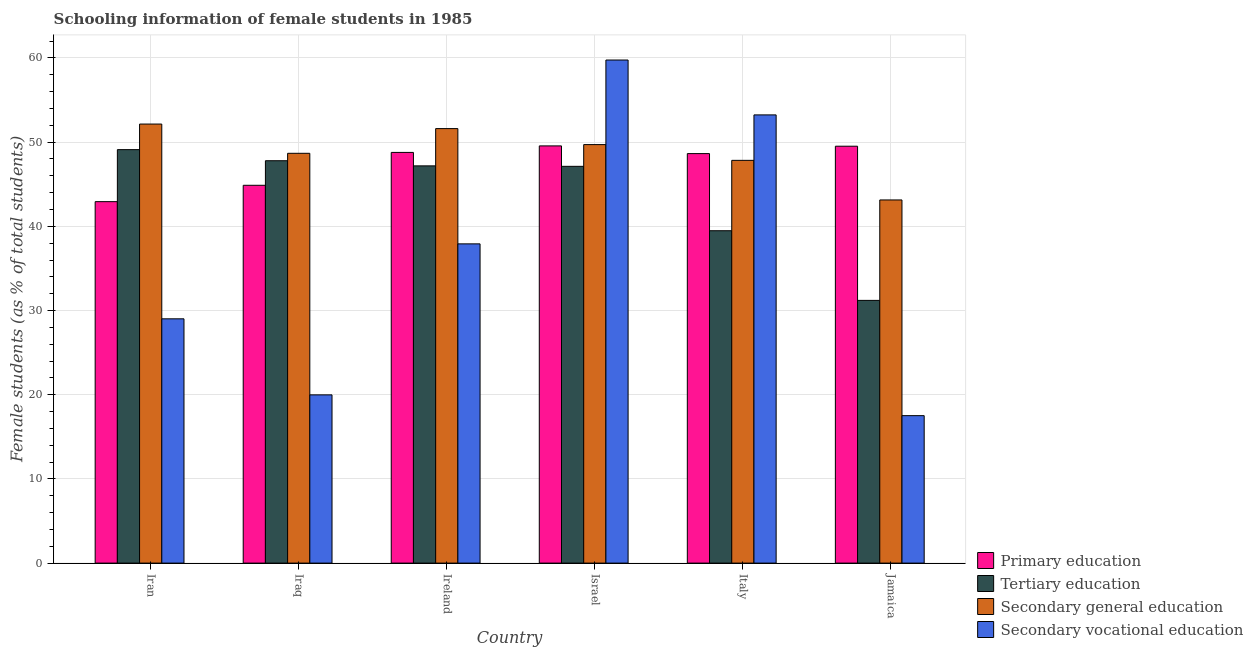How many groups of bars are there?
Give a very brief answer. 6. Are the number of bars per tick equal to the number of legend labels?
Give a very brief answer. Yes. How many bars are there on the 5th tick from the left?
Your answer should be very brief. 4. What is the label of the 4th group of bars from the left?
Ensure brevity in your answer.  Israel. In how many cases, is the number of bars for a given country not equal to the number of legend labels?
Your response must be concise. 0. What is the percentage of female students in tertiary education in Ireland?
Your answer should be compact. 47.18. Across all countries, what is the maximum percentage of female students in secondary vocational education?
Ensure brevity in your answer.  59.76. Across all countries, what is the minimum percentage of female students in secondary vocational education?
Offer a terse response. 17.51. In which country was the percentage of female students in primary education maximum?
Offer a very short reply. Israel. In which country was the percentage of female students in secondary vocational education minimum?
Provide a succinct answer. Jamaica. What is the total percentage of female students in primary education in the graph?
Make the answer very short. 284.31. What is the difference between the percentage of female students in primary education in Iraq and that in Italy?
Make the answer very short. -3.76. What is the difference between the percentage of female students in primary education in Iran and the percentage of female students in secondary education in Iraq?
Offer a terse response. -5.74. What is the average percentage of female students in secondary vocational education per country?
Your response must be concise. 36.24. What is the difference between the percentage of female students in secondary vocational education and percentage of female students in tertiary education in Israel?
Ensure brevity in your answer.  12.63. What is the ratio of the percentage of female students in primary education in Israel to that in Italy?
Offer a terse response. 1.02. Is the percentage of female students in secondary vocational education in Iran less than that in Ireland?
Give a very brief answer. Yes. What is the difference between the highest and the second highest percentage of female students in secondary vocational education?
Ensure brevity in your answer.  6.52. What is the difference between the highest and the lowest percentage of female students in secondary vocational education?
Offer a terse response. 42.24. Is the sum of the percentage of female students in secondary education in Iran and Jamaica greater than the maximum percentage of female students in secondary vocational education across all countries?
Make the answer very short. Yes. Is it the case that in every country, the sum of the percentage of female students in secondary vocational education and percentage of female students in tertiary education is greater than the sum of percentage of female students in secondary education and percentage of female students in primary education?
Offer a terse response. No. What does the 2nd bar from the left in Iran represents?
Make the answer very short. Tertiary education. What does the 3rd bar from the right in Iran represents?
Provide a short and direct response. Tertiary education. How many bars are there?
Your answer should be very brief. 24. What is the difference between two consecutive major ticks on the Y-axis?
Your answer should be very brief. 10. How are the legend labels stacked?
Ensure brevity in your answer.  Vertical. What is the title of the graph?
Provide a short and direct response. Schooling information of female students in 1985. Does "Fiscal policy" appear as one of the legend labels in the graph?
Provide a short and direct response. No. What is the label or title of the Y-axis?
Give a very brief answer. Female students (as % of total students). What is the Female students (as % of total students) in Primary education in Iran?
Give a very brief answer. 42.93. What is the Female students (as % of total students) of Tertiary education in Iran?
Make the answer very short. 49.11. What is the Female students (as % of total students) in Secondary general education in Iran?
Your response must be concise. 52.15. What is the Female students (as % of total students) of Secondary vocational education in Iran?
Offer a very short reply. 29.02. What is the Female students (as % of total students) in Primary education in Iraq?
Make the answer very short. 44.88. What is the Female students (as % of total students) in Tertiary education in Iraq?
Your answer should be very brief. 47.79. What is the Female students (as % of total students) in Secondary general education in Iraq?
Your answer should be compact. 48.68. What is the Female students (as % of total students) of Secondary vocational education in Iraq?
Offer a terse response. 19.98. What is the Female students (as % of total students) in Primary education in Ireland?
Keep it short and to the point. 48.78. What is the Female students (as % of total students) in Tertiary education in Ireland?
Provide a succinct answer. 47.18. What is the Female students (as % of total students) of Secondary general education in Ireland?
Offer a very short reply. 51.61. What is the Female students (as % of total students) of Secondary vocational education in Ireland?
Your answer should be very brief. 37.92. What is the Female students (as % of total students) in Primary education in Israel?
Your answer should be very brief. 49.56. What is the Female students (as % of total students) of Tertiary education in Israel?
Make the answer very short. 47.13. What is the Female students (as % of total students) in Secondary general education in Israel?
Make the answer very short. 49.71. What is the Female students (as % of total students) in Secondary vocational education in Israel?
Provide a short and direct response. 59.76. What is the Female students (as % of total students) in Primary education in Italy?
Ensure brevity in your answer.  48.64. What is the Female students (as % of total students) of Tertiary education in Italy?
Offer a very short reply. 39.48. What is the Female students (as % of total students) in Secondary general education in Italy?
Give a very brief answer. 47.84. What is the Female students (as % of total students) of Secondary vocational education in Italy?
Ensure brevity in your answer.  53.24. What is the Female students (as % of total students) in Primary education in Jamaica?
Ensure brevity in your answer.  49.52. What is the Female students (as % of total students) in Tertiary education in Jamaica?
Your answer should be very brief. 31.21. What is the Female students (as % of total students) in Secondary general education in Jamaica?
Ensure brevity in your answer.  43.14. What is the Female students (as % of total students) in Secondary vocational education in Jamaica?
Provide a succinct answer. 17.51. Across all countries, what is the maximum Female students (as % of total students) of Primary education?
Provide a succinct answer. 49.56. Across all countries, what is the maximum Female students (as % of total students) of Tertiary education?
Make the answer very short. 49.11. Across all countries, what is the maximum Female students (as % of total students) in Secondary general education?
Provide a short and direct response. 52.15. Across all countries, what is the maximum Female students (as % of total students) of Secondary vocational education?
Ensure brevity in your answer.  59.76. Across all countries, what is the minimum Female students (as % of total students) in Primary education?
Provide a short and direct response. 42.93. Across all countries, what is the minimum Female students (as % of total students) in Tertiary education?
Offer a terse response. 31.21. Across all countries, what is the minimum Female students (as % of total students) in Secondary general education?
Your response must be concise. 43.14. Across all countries, what is the minimum Female students (as % of total students) of Secondary vocational education?
Your response must be concise. 17.51. What is the total Female students (as % of total students) of Primary education in the graph?
Give a very brief answer. 284.31. What is the total Female students (as % of total students) of Tertiary education in the graph?
Give a very brief answer. 261.9. What is the total Female students (as % of total students) in Secondary general education in the graph?
Provide a succinct answer. 293.12. What is the total Female students (as % of total students) in Secondary vocational education in the graph?
Ensure brevity in your answer.  217.43. What is the difference between the Female students (as % of total students) of Primary education in Iran and that in Iraq?
Keep it short and to the point. -1.94. What is the difference between the Female students (as % of total students) in Tertiary education in Iran and that in Iraq?
Provide a short and direct response. 1.32. What is the difference between the Female students (as % of total students) of Secondary general education in Iran and that in Iraq?
Offer a terse response. 3.47. What is the difference between the Female students (as % of total students) of Secondary vocational education in Iran and that in Iraq?
Give a very brief answer. 9.03. What is the difference between the Female students (as % of total students) of Primary education in Iran and that in Ireland?
Ensure brevity in your answer.  -5.85. What is the difference between the Female students (as % of total students) of Tertiary education in Iran and that in Ireland?
Keep it short and to the point. 1.93. What is the difference between the Female students (as % of total students) of Secondary general education in Iran and that in Ireland?
Your answer should be very brief. 0.54. What is the difference between the Female students (as % of total students) in Secondary vocational education in Iran and that in Ireland?
Give a very brief answer. -8.9. What is the difference between the Female students (as % of total students) of Primary education in Iran and that in Israel?
Your answer should be compact. -6.62. What is the difference between the Female students (as % of total students) of Tertiary education in Iran and that in Israel?
Give a very brief answer. 1.98. What is the difference between the Female students (as % of total students) of Secondary general education in Iran and that in Israel?
Your response must be concise. 2.44. What is the difference between the Female students (as % of total students) of Secondary vocational education in Iran and that in Israel?
Offer a very short reply. -30.74. What is the difference between the Female students (as % of total students) in Primary education in Iran and that in Italy?
Keep it short and to the point. -5.71. What is the difference between the Female students (as % of total students) of Tertiary education in Iran and that in Italy?
Your response must be concise. 9.63. What is the difference between the Female students (as % of total students) of Secondary general education in Iran and that in Italy?
Make the answer very short. 4.31. What is the difference between the Female students (as % of total students) in Secondary vocational education in Iran and that in Italy?
Your answer should be very brief. -24.22. What is the difference between the Female students (as % of total students) of Primary education in Iran and that in Jamaica?
Your answer should be compact. -6.59. What is the difference between the Female students (as % of total students) in Tertiary education in Iran and that in Jamaica?
Provide a succinct answer. 17.91. What is the difference between the Female students (as % of total students) of Secondary general education in Iran and that in Jamaica?
Offer a terse response. 9.01. What is the difference between the Female students (as % of total students) in Secondary vocational education in Iran and that in Jamaica?
Your answer should be compact. 11.5. What is the difference between the Female students (as % of total students) of Primary education in Iraq and that in Ireland?
Provide a succinct answer. -3.9. What is the difference between the Female students (as % of total students) of Tertiary education in Iraq and that in Ireland?
Your answer should be compact. 0.61. What is the difference between the Female students (as % of total students) of Secondary general education in Iraq and that in Ireland?
Your answer should be compact. -2.94. What is the difference between the Female students (as % of total students) in Secondary vocational education in Iraq and that in Ireland?
Keep it short and to the point. -17.94. What is the difference between the Female students (as % of total students) in Primary education in Iraq and that in Israel?
Provide a short and direct response. -4.68. What is the difference between the Female students (as % of total students) in Tertiary education in Iraq and that in Israel?
Provide a short and direct response. 0.67. What is the difference between the Female students (as % of total students) in Secondary general education in Iraq and that in Israel?
Offer a terse response. -1.03. What is the difference between the Female students (as % of total students) in Secondary vocational education in Iraq and that in Israel?
Offer a terse response. -39.77. What is the difference between the Female students (as % of total students) in Primary education in Iraq and that in Italy?
Give a very brief answer. -3.76. What is the difference between the Female students (as % of total students) of Tertiary education in Iraq and that in Italy?
Provide a short and direct response. 8.31. What is the difference between the Female students (as % of total students) in Secondary general education in Iraq and that in Italy?
Provide a succinct answer. 0.84. What is the difference between the Female students (as % of total students) in Secondary vocational education in Iraq and that in Italy?
Give a very brief answer. -33.26. What is the difference between the Female students (as % of total students) in Primary education in Iraq and that in Jamaica?
Keep it short and to the point. -4.64. What is the difference between the Female students (as % of total students) of Tertiary education in Iraq and that in Jamaica?
Keep it short and to the point. 16.59. What is the difference between the Female students (as % of total students) in Secondary general education in Iraq and that in Jamaica?
Make the answer very short. 5.54. What is the difference between the Female students (as % of total students) in Secondary vocational education in Iraq and that in Jamaica?
Provide a succinct answer. 2.47. What is the difference between the Female students (as % of total students) in Primary education in Ireland and that in Israel?
Offer a very short reply. -0.77. What is the difference between the Female students (as % of total students) of Tertiary education in Ireland and that in Israel?
Your answer should be compact. 0.06. What is the difference between the Female students (as % of total students) in Secondary general education in Ireland and that in Israel?
Provide a succinct answer. 1.9. What is the difference between the Female students (as % of total students) of Secondary vocational education in Ireland and that in Israel?
Give a very brief answer. -21.84. What is the difference between the Female students (as % of total students) of Primary education in Ireland and that in Italy?
Keep it short and to the point. 0.14. What is the difference between the Female students (as % of total students) of Tertiary education in Ireland and that in Italy?
Your response must be concise. 7.7. What is the difference between the Female students (as % of total students) of Secondary general education in Ireland and that in Italy?
Keep it short and to the point. 3.77. What is the difference between the Female students (as % of total students) of Secondary vocational education in Ireland and that in Italy?
Your answer should be very brief. -15.32. What is the difference between the Female students (as % of total students) in Primary education in Ireland and that in Jamaica?
Provide a succinct answer. -0.74. What is the difference between the Female students (as % of total students) in Tertiary education in Ireland and that in Jamaica?
Your answer should be compact. 15.98. What is the difference between the Female students (as % of total students) of Secondary general education in Ireland and that in Jamaica?
Your answer should be compact. 8.48. What is the difference between the Female students (as % of total students) in Secondary vocational education in Ireland and that in Jamaica?
Offer a terse response. 20.4. What is the difference between the Female students (as % of total students) of Primary education in Israel and that in Italy?
Provide a succinct answer. 0.92. What is the difference between the Female students (as % of total students) of Tertiary education in Israel and that in Italy?
Keep it short and to the point. 7.65. What is the difference between the Female students (as % of total students) of Secondary general education in Israel and that in Italy?
Your response must be concise. 1.87. What is the difference between the Female students (as % of total students) of Secondary vocational education in Israel and that in Italy?
Offer a very short reply. 6.52. What is the difference between the Female students (as % of total students) of Primary education in Israel and that in Jamaica?
Provide a succinct answer. 0.04. What is the difference between the Female students (as % of total students) of Tertiary education in Israel and that in Jamaica?
Ensure brevity in your answer.  15.92. What is the difference between the Female students (as % of total students) of Secondary general education in Israel and that in Jamaica?
Offer a terse response. 6.57. What is the difference between the Female students (as % of total students) in Secondary vocational education in Israel and that in Jamaica?
Provide a succinct answer. 42.24. What is the difference between the Female students (as % of total students) in Primary education in Italy and that in Jamaica?
Your answer should be very brief. -0.88. What is the difference between the Female students (as % of total students) of Tertiary education in Italy and that in Jamaica?
Offer a terse response. 8.27. What is the difference between the Female students (as % of total students) of Secondary general education in Italy and that in Jamaica?
Your answer should be very brief. 4.7. What is the difference between the Female students (as % of total students) of Secondary vocational education in Italy and that in Jamaica?
Offer a terse response. 35.72. What is the difference between the Female students (as % of total students) of Primary education in Iran and the Female students (as % of total students) of Tertiary education in Iraq?
Ensure brevity in your answer.  -4.86. What is the difference between the Female students (as % of total students) in Primary education in Iran and the Female students (as % of total students) in Secondary general education in Iraq?
Offer a terse response. -5.74. What is the difference between the Female students (as % of total students) of Primary education in Iran and the Female students (as % of total students) of Secondary vocational education in Iraq?
Give a very brief answer. 22.95. What is the difference between the Female students (as % of total students) of Tertiary education in Iran and the Female students (as % of total students) of Secondary general education in Iraq?
Offer a very short reply. 0.44. What is the difference between the Female students (as % of total students) of Tertiary education in Iran and the Female students (as % of total students) of Secondary vocational education in Iraq?
Keep it short and to the point. 29.13. What is the difference between the Female students (as % of total students) in Secondary general education in Iran and the Female students (as % of total students) in Secondary vocational education in Iraq?
Your answer should be compact. 32.17. What is the difference between the Female students (as % of total students) of Primary education in Iran and the Female students (as % of total students) of Tertiary education in Ireland?
Your response must be concise. -4.25. What is the difference between the Female students (as % of total students) of Primary education in Iran and the Female students (as % of total students) of Secondary general education in Ireland?
Give a very brief answer. -8.68. What is the difference between the Female students (as % of total students) of Primary education in Iran and the Female students (as % of total students) of Secondary vocational education in Ireland?
Keep it short and to the point. 5.01. What is the difference between the Female students (as % of total students) of Tertiary education in Iran and the Female students (as % of total students) of Secondary general education in Ireland?
Ensure brevity in your answer.  -2.5. What is the difference between the Female students (as % of total students) of Tertiary education in Iran and the Female students (as % of total students) of Secondary vocational education in Ireland?
Keep it short and to the point. 11.19. What is the difference between the Female students (as % of total students) of Secondary general education in Iran and the Female students (as % of total students) of Secondary vocational education in Ireland?
Give a very brief answer. 14.23. What is the difference between the Female students (as % of total students) of Primary education in Iran and the Female students (as % of total students) of Tertiary education in Israel?
Ensure brevity in your answer.  -4.19. What is the difference between the Female students (as % of total students) in Primary education in Iran and the Female students (as % of total students) in Secondary general education in Israel?
Provide a succinct answer. -6.78. What is the difference between the Female students (as % of total students) in Primary education in Iran and the Female students (as % of total students) in Secondary vocational education in Israel?
Offer a terse response. -16.82. What is the difference between the Female students (as % of total students) of Tertiary education in Iran and the Female students (as % of total students) of Secondary general education in Israel?
Your response must be concise. -0.6. What is the difference between the Female students (as % of total students) in Tertiary education in Iran and the Female students (as % of total students) in Secondary vocational education in Israel?
Your response must be concise. -10.64. What is the difference between the Female students (as % of total students) of Secondary general education in Iran and the Female students (as % of total students) of Secondary vocational education in Israel?
Make the answer very short. -7.61. What is the difference between the Female students (as % of total students) of Primary education in Iran and the Female students (as % of total students) of Tertiary education in Italy?
Provide a short and direct response. 3.45. What is the difference between the Female students (as % of total students) of Primary education in Iran and the Female students (as % of total students) of Secondary general education in Italy?
Offer a very short reply. -4.91. What is the difference between the Female students (as % of total students) of Primary education in Iran and the Female students (as % of total students) of Secondary vocational education in Italy?
Give a very brief answer. -10.3. What is the difference between the Female students (as % of total students) in Tertiary education in Iran and the Female students (as % of total students) in Secondary general education in Italy?
Your response must be concise. 1.27. What is the difference between the Female students (as % of total students) of Tertiary education in Iran and the Female students (as % of total students) of Secondary vocational education in Italy?
Provide a short and direct response. -4.13. What is the difference between the Female students (as % of total students) of Secondary general education in Iran and the Female students (as % of total students) of Secondary vocational education in Italy?
Provide a succinct answer. -1.09. What is the difference between the Female students (as % of total students) of Primary education in Iran and the Female students (as % of total students) of Tertiary education in Jamaica?
Give a very brief answer. 11.73. What is the difference between the Female students (as % of total students) of Primary education in Iran and the Female students (as % of total students) of Secondary general education in Jamaica?
Offer a terse response. -0.2. What is the difference between the Female students (as % of total students) in Primary education in Iran and the Female students (as % of total students) in Secondary vocational education in Jamaica?
Offer a very short reply. 25.42. What is the difference between the Female students (as % of total students) in Tertiary education in Iran and the Female students (as % of total students) in Secondary general education in Jamaica?
Make the answer very short. 5.98. What is the difference between the Female students (as % of total students) in Tertiary education in Iran and the Female students (as % of total students) in Secondary vocational education in Jamaica?
Make the answer very short. 31.6. What is the difference between the Female students (as % of total students) of Secondary general education in Iran and the Female students (as % of total students) of Secondary vocational education in Jamaica?
Your response must be concise. 34.64. What is the difference between the Female students (as % of total students) of Primary education in Iraq and the Female students (as % of total students) of Tertiary education in Ireland?
Offer a very short reply. -2.31. What is the difference between the Female students (as % of total students) of Primary education in Iraq and the Female students (as % of total students) of Secondary general education in Ireland?
Your response must be concise. -6.73. What is the difference between the Female students (as % of total students) in Primary education in Iraq and the Female students (as % of total students) in Secondary vocational education in Ireland?
Give a very brief answer. 6.96. What is the difference between the Female students (as % of total students) of Tertiary education in Iraq and the Female students (as % of total students) of Secondary general education in Ireland?
Give a very brief answer. -3.82. What is the difference between the Female students (as % of total students) of Tertiary education in Iraq and the Female students (as % of total students) of Secondary vocational education in Ireland?
Your answer should be compact. 9.87. What is the difference between the Female students (as % of total students) in Secondary general education in Iraq and the Female students (as % of total students) in Secondary vocational education in Ireland?
Provide a succinct answer. 10.76. What is the difference between the Female students (as % of total students) of Primary education in Iraq and the Female students (as % of total students) of Tertiary education in Israel?
Ensure brevity in your answer.  -2.25. What is the difference between the Female students (as % of total students) in Primary education in Iraq and the Female students (as % of total students) in Secondary general education in Israel?
Your answer should be very brief. -4.83. What is the difference between the Female students (as % of total students) in Primary education in Iraq and the Female students (as % of total students) in Secondary vocational education in Israel?
Offer a terse response. -14.88. What is the difference between the Female students (as % of total students) of Tertiary education in Iraq and the Female students (as % of total students) of Secondary general education in Israel?
Provide a succinct answer. -1.92. What is the difference between the Female students (as % of total students) in Tertiary education in Iraq and the Female students (as % of total students) in Secondary vocational education in Israel?
Make the answer very short. -11.96. What is the difference between the Female students (as % of total students) in Secondary general education in Iraq and the Female students (as % of total students) in Secondary vocational education in Israel?
Keep it short and to the point. -11.08. What is the difference between the Female students (as % of total students) of Primary education in Iraq and the Female students (as % of total students) of Tertiary education in Italy?
Your response must be concise. 5.4. What is the difference between the Female students (as % of total students) in Primary education in Iraq and the Female students (as % of total students) in Secondary general education in Italy?
Ensure brevity in your answer.  -2.96. What is the difference between the Female students (as % of total students) in Primary education in Iraq and the Female students (as % of total students) in Secondary vocational education in Italy?
Provide a succinct answer. -8.36. What is the difference between the Female students (as % of total students) in Tertiary education in Iraq and the Female students (as % of total students) in Secondary general education in Italy?
Keep it short and to the point. -0.05. What is the difference between the Female students (as % of total students) of Tertiary education in Iraq and the Female students (as % of total students) of Secondary vocational education in Italy?
Provide a short and direct response. -5.45. What is the difference between the Female students (as % of total students) of Secondary general education in Iraq and the Female students (as % of total students) of Secondary vocational education in Italy?
Your answer should be very brief. -4.56. What is the difference between the Female students (as % of total students) of Primary education in Iraq and the Female students (as % of total students) of Tertiary education in Jamaica?
Provide a short and direct response. 13.67. What is the difference between the Female students (as % of total students) in Primary education in Iraq and the Female students (as % of total students) in Secondary general education in Jamaica?
Your answer should be compact. 1.74. What is the difference between the Female students (as % of total students) in Primary education in Iraq and the Female students (as % of total students) in Secondary vocational education in Jamaica?
Offer a very short reply. 27.36. What is the difference between the Female students (as % of total students) of Tertiary education in Iraq and the Female students (as % of total students) of Secondary general education in Jamaica?
Make the answer very short. 4.66. What is the difference between the Female students (as % of total students) in Tertiary education in Iraq and the Female students (as % of total students) in Secondary vocational education in Jamaica?
Make the answer very short. 30.28. What is the difference between the Female students (as % of total students) in Secondary general education in Iraq and the Female students (as % of total students) in Secondary vocational education in Jamaica?
Keep it short and to the point. 31.16. What is the difference between the Female students (as % of total students) in Primary education in Ireland and the Female students (as % of total students) in Tertiary education in Israel?
Provide a succinct answer. 1.65. What is the difference between the Female students (as % of total students) in Primary education in Ireland and the Female students (as % of total students) in Secondary general education in Israel?
Your response must be concise. -0.93. What is the difference between the Female students (as % of total students) of Primary education in Ireland and the Female students (as % of total students) of Secondary vocational education in Israel?
Offer a very short reply. -10.97. What is the difference between the Female students (as % of total students) in Tertiary education in Ireland and the Female students (as % of total students) in Secondary general education in Israel?
Offer a very short reply. -2.53. What is the difference between the Female students (as % of total students) of Tertiary education in Ireland and the Female students (as % of total students) of Secondary vocational education in Israel?
Your answer should be compact. -12.57. What is the difference between the Female students (as % of total students) of Secondary general education in Ireland and the Female students (as % of total students) of Secondary vocational education in Israel?
Keep it short and to the point. -8.14. What is the difference between the Female students (as % of total students) of Primary education in Ireland and the Female students (as % of total students) of Tertiary education in Italy?
Give a very brief answer. 9.3. What is the difference between the Female students (as % of total students) of Primary education in Ireland and the Female students (as % of total students) of Secondary general education in Italy?
Keep it short and to the point. 0.94. What is the difference between the Female students (as % of total students) in Primary education in Ireland and the Female students (as % of total students) in Secondary vocational education in Italy?
Make the answer very short. -4.46. What is the difference between the Female students (as % of total students) in Tertiary education in Ireland and the Female students (as % of total students) in Secondary general education in Italy?
Offer a very short reply. -0.66. What is the difference between the Female students (as % of total students) in Tertiary education in Ireland and the Female students (as % of total students) in Secondary vocational education in Italy?
Keep it short and to the point. -6.06. What is the difference between the Female students (as % of total students) of Secondary general education in Ireland and the Female students (as % of total students) of Secondary vocational education in Italy?
Offer a very short reply. -1.63. What is the difference between the Female students (as % of total students) in Primary education in Ireland and the Female students (as % of total students) in Tertiary education in Jamaica?
Keep it short and to the point. 17.58. What is the difference between the Female students (as % of total students) in Primary education in Ireland and the Female students (as % of total students) in Secondary general education in Jamaica?
Ensure brevity in your answer.  5.65. What is the difference between the Female students (as % of total students) in Primary education in Ireland and the Female students (as % of total students) in Secondary vocational education in Jamaica?
Provide a short and direct response. 31.27. What is the difference between the Female students (as % of total students) in Tertiary education in Ireland and the Female students (as % of total students) in Secondary general education in Jamaica?
Give a very brief answer. 4.05. What is the difference between the Female students (as % of total students) of Tertiary education in Ireland and the Female students (as % of total students) of Secondary vocational education in Jamaica?
Give a very brief answer. 29.67. What is the difference between the Female students (as % of total students) in Secondary general education in Ireland and the Female students (as % of total students) in Secondary vocational education in Jamaica?
Keep it short and to the point. 34.1. What is the difference between the Female students (as % of total students) of Primary education in Israel and the Female students (as % of total students) of Tertiary education in Italy?
Provide a short and direct response. 10.08. What is the difference between the Female students (as % of total students) in Primary education in Israel and the Female students (as % of total students) in Secondary general education in Italy?
Make the answer very short. 1.72. What is the difference between the Female students (as % of total students) of Primary education in Israel and the Female students (as % of total students) of Secondary vocational education in Italy?
Keep it short and to the point. -3.68. What is the difference between the Female students (as % of total students) of Tertiary education in Israel and the Female students (as % of total students) of Secondary general education in Italy?
Give a very brief answer. -0.71. What is the difference between the Female students (as % of total students) of Tertiary education in Israel and the Female students (as % of total students) of Secondary vocational education in Italy?
Give a very brief answer. -6.11. What is the difference between the Female students (as % of total students) in Secondary general education in Israel and the Female students (as % of total students) in Secondary vocational education in Italy?
Offer a terse response. -3.53. What is the difference between the Female students (as % of total students) in Primary education in Israel and the Female students (as % of total students) in Tertiary education in Jamaica?
Your answer should be compact. 18.35. What is the difference between the Female students (as % of total students) in Primary education in Israel and the Female students (as % of total students) in Secondary general education in Jamaica?
Your answer should be very brief. 6.42. What is the difference between the Female students (as % of total students) in Primary education in Israel and the Female students (as % of total students) in Secondary vocational education in Jamaica?
Give a very brief answer. 32.04. What is the difference between the Female students (as % of total students) of Tertiary education in Israel and the Female students (as % of total students) of Secondary general education in Jamaica?
Give a very brief answer. 3.99. What is the difference between the Female students (as % of total students) in Tertiary education in Israel and the Female students (as % of total students) in Secondary vocational education in Jamaica?
Your answer should be very brief. 29.61. What is the difference between the Female students (as % of total students) of Secondary general education in Israel and the Female students (as % of total students) of Secondary vocational education in Jamaica?
Offer a very short reply. 32.19. What is the difference between the Female students (as % of total students) of Primary education in Italy and the Female students (as % of total students) of Tertiary education in Jamaica?
Keep it short and to the point. 17.43. What is the difference between the Female students (as % of total students) in Primary education in Italy and the Female students (as % of total students) in Secondary general education in Jamaica?
Give a very brief answer. 5.5. What is the difference between the Female students (as % of total students) in Primary education in Italy and the Female students (as % of total students) in Secondary vocational education in Jamaica?
Give a very brief answer. 31.13. What is the difference between the Female students (as % of total students) in Tertiary education in Italy and the Female students (as % of total students) in Secondary general education in Jamaica?
Your answer should be compact. -3.66. What is the difference between the Female students (as % of total students) in Tertiary education in Italy and the Female students (as % of total students) in Secondary vocational education in Jamaica?
Provide a succinct answer. 21.96. What is the difference between the Female students (as % of total students) of Secondary general education in Italy and the Female students (as % of total students) of Secondary vocational education in Jamaica?
Keep it short and to the point. 30.32. What is the average Female students (as % of total students) in Primary education per country?
Your answer should be very brief. 47.38. What is the average Female students (as % of total students) in Tertiary education per country?
Ensure brevity in your answer.  43.65. What is the average Female students (as % of total students) in Secondary general education per country?
Your answer should be very brief. 48.85. What is the average Female students (as % of total students) in Secondary vocational education per country?
Ensure brevity in your answer.  36.24. What is the difference between the Female students (as % of total students) in Primary education and Female students (as % of total students) in Tertiary education in Iran?
Make the answer very short. -6.18. What is the difference between the Female students (as % of total students) in Primary education and Female students (as % of total students) in Secondary general education in Iran?
Provide a short and direct response. -9.22. What is the difference between the Female students (as % of total students) in Primary education and Female students (as % of total students) in Secondary vocational education in Iran?
Make the answer very short. 13.92. What is the difference between the Female students (as % of total students) in Tertiary education and Female students (as % of total students) in Secondary general education in Iran?
Give a very brief answer. -3.04. What is the difference between the Female students (as % of total students) of Tertiary education and Female students (as % of total students) of Secondary vocational education in Iran?
Offer a terse response. 20.1. What is the difference between the Female students (as % of total students) in Secondary general education and Female students (as % of total students) in Secondary vocational education in Iran?
Offer a terse response. 23.13. What is the difference between the Female students (as % of total students) in Primary education and Female students (as % of total students) in Tertiary education in Iraq?
Your answer should be very brief. -2.92. What is the difference between the Female students (as % of total students) of Primary education and Female students (as % of total students) of Secondary general education in Iraq?
Provide a short and direct response. -3.8. What is the difference between the Female students (as % of total students) in Primary education and Female students (as % of total students) in Secondary vocational education in Iraq?
Make the answer very short. 24.89. What is the difference between the Female students (as % of total students) in Tertiary education and Female students (as % of total students) in Secondary general education in Iraq?
Ensure brevity in your answer.  -0.88. What is the difference between the Female students (as % of total students) of Tertiary education and Female students (as % of total students) of Secondary vocational education in Iraq?
Your response must be concise. 27.81. What is the difference between the Female students (as % of total students) in Secondary general education and Female students (as % of total students) in Secondary vocational education in Iraq?
Give a very brief answer. 28.69. What is the difference between the Female students (as % of total students) in Primary education and Female students (as % of total students) in Tertiary education in Ireland?
Make the answer very short. 1.6. What is the difference between the Female students (as % of total students) of Primary education and Female students (as % of total students) of Secondary general education in Ireland?
Your answer should be compact. -2.83. What is the difference between the Female students (as % of total students) in Primary education and Female students (as % of total students) in Secondary vocational education in Ireland?
Provide a short and direct response. 10.86. What is the difference between the Female students (as % of total students) in Tertiary education and Female students (as % of total students) in Secondary general education in Ireland?
Your answer should be compact. -4.43. What is the difference between the Female students (as % of total students) of Tertiary education and Female students (as % of total students) of Secondary vocational education in Ireland?
Your response must be concise. 9.26. What is the difference between the Female students (as % of total students) in Secondary general education and Female students (as % of total students) in Secondary vocational education in Ireland?
Provide a succinct answer. 13.69. What is the difference between the Female students (as % of total students) of Primary education and Female students (as % of total students) of Tertiary education in Israel?
Offer a terse response. 2.43. What is the difference between the Female students (as % of total students) in Primary education and Female students (as % of total students) in Secondary general education in Israel?
Your answer should be very brief. -0.15. What is the difference between the Female students (as % of total students) in Primary education and Female students (as % of total students) in Secondary vocational education in Israel?
Offer a terse response. -10.2. What is the difference between the Female students (as % of total students) in Tertiary education and Female students (as % of total students) in Secondary general education in Israel?
Provide a succinct answer. -2.58. What is the difference between the Female students (as % of total students) in Tertiary education and Female students (as % of total students) in Secondary vocational education in Israel?
Make the answer very short. -12.63. What is the difference between the Female students (as % of total students) of Secondary general education and Female students (as % of total students) of Secondary vocational education in Israel?
Provide a succinct answer. -10.05. What is the difference between the Female students (as % of total students) of Primary education and Female students (as % of total students) of Tertiary education in Italy?
Give a very brief answer. 9.16. What is the difference between the Female students (as % of total students) in Primary education and Female students (as % of total students) in Secondary general education in Italy?
Your answer should be very brief. 0.8. What is the difference between the Female students (as % of total students) of Primary education and Female students (as % of total students) of Secondary vocational education in Italy?
Offer a terse response. -4.6. What is the difference between the Female students (as % of total students) in Tertiary education and Female students (as % of total students) in Secondary general education in Italy?
Keep it short and to the point. -8.36. What is the difference between the Female students (as % of total students) of Tertiary education and Female students (as % of total students) of Secondary vocational education in Italy?
Offer a very short reply. -13.76. What is the difference between the Female students (as % of total students) of Secondary general education and Female students (as % of total students) of Secondary vocational education in Italy?
Provide a short and direct response. -5.4. What is the difference between the Female students (as % of total students) in Primary education and Female students (as % of total students) in Tertiary education in Jamaica?
Your answer should be very brief. 18.31. What is the difference between the Female students (as % of total students) in Primary education and Female students (as % of total students) in Secondary general education in Jamaica?
Offer a terse response. 6.38. What is the difference between the Female students (as % of total students) in Primary education and Female students (as % of total students) in Secondary vocational education in Jamaica?
Your response must be concise. 32. What is the difference between the Female students (as % of total students) of Tertiary education and Female students (as % of total students) of Secondary general education in Jamaica?
Offer a very short reply. -11.93. What is the difference between the Female students (as % of total students) in Tertiary education and Female students (as % of total students) in Secondary vocational education in Jamaica?
Your answer should be compact. 13.69. What is the difference between the Female students (as % of total students) in Secondary general education and Female students (as % of total students) in Secondary vocational education in Jamaica?
Offer a very short reply. 25.62. What is the ratio of the Female students (as % of total students) in Primary education in Iran to that in Iraq?
Make the answer very short. 0.96. What is the ratio of the Female students (as % of total students) of Tertiary education in Iran to that in Iraq?
Give a very brief answer. 1.03. What is the ratio of the Female students (as % of total students) in Secondary general education in Iran to that in Iraq?
Ensure brevity in your answer.  1.07. What is the ratio of the Female students (as % of total students) in Secondary vocational education in Iran to that in Iraq?
Ensure brevity in your answer.  1.45. What is the ratio of the Female students (as % of total students) in Primary education in Iran to that in Ireland?
Provide a succinct answer. 0.88. What is the ratio of the Female students (as % of total students) of Tertiary education in Iran to that in Ireland?
Make the answer very short. 1.04. What is the ratio of the Female students (as % of total students) of Secondary general education in Iran to that in Ireland?
Offer a very short reply. 1.01. What is the ratio of the Female students (as % of total students) of Secondary vocational education in Iran to that in Ireland?
Offer a very short reply. 0.77. What is the ratio of the Female students (as % of total students) in Primary education in Iran to that in Israel?
Offer a terse response. 0.87. What is the ratio of the Female students (as % of total students) of Tertiary education in Iran to that in Israel?
Make the answer very short. 1.04. What is the ratio of the Female students (as % of total students) in Secondary general education in Iran to that in Israel?
Offer a very short reply. 1.05. What is the ratio of the Female students (as % of total students) of Secondary vocational education in Iran to that in Israel?
Provide a short and direct response. 0.49. What is the ratio of the Female students (as % of total students) of Primary education in Iran to that in Italy?
Provide a short and direct response. 0.88. What is the ratio of the Female students (as % of total students) of Tertiary education in Iran to that in Italy?
Your answer should be compact. 1.24. What is the ratio of the Female students (as % of total students) of Secondary general education in Iran to that in Italy?
Make the answer very short. 1.09. What is the ratio of the Female students (as % of total students) of Secondary vocational education in Iran to that in Italy?
Your answer should be very brief. 0.55. What is the ratio of the Female students (as % of total students) in Primary education in Iran to that in Jamaica?
Provide a succinct answer. 0.87. What is the ratio of the Female students (as % of total students) of Tertiary education in Iran to that in Jamaica?
Your answer should be very brief. 1.57. What is the ratio of the Female students (as % of total students) of Secondary general education in Iran to that in Jamaica?
Offer a terse response. 1.21. What is the ratio of the Female students (as % of total students) of Secondary vocational education in Iran to that in Jamaica?
Give a very brief answer. 1.66. What is the ratio of the Female students (as % of total students) of Primary education in Iraq to that in Ireland?
Keep it short and to the point. 0.92. What is the ratio of the Female students (as % of total students) in Tertiary education in Iraq to that in Ireland?
Your answer should be very brief. 1.01. What is the ratio of the Female students (as % of total students) of Secondary general education in Iraq to that in Ireland?
Your response must be concise. 0.94. What is the ratio of the Female students (as % of total students) of Secondary vocational education in Iraq to that in Ireland?
Ensure brevity in your answer.  0.53. What is the ratio of the Female students (as % of total students) in Primary education in Iraq to that in Israel?
Your answer should be compact. 0.91. What is the ratio of the Female students (as % of total students) of Tertiary education in Iraq to that in Israel?
Your answer should be compact. 1.01. What is the ratio of the Female students (as % of total students) of Secondary general education in Iraq to that in Israel?
Provide a succinct answer. 0.98. What is the ratio of the Female students (as % of total students) of Secondary vocational education in Iraq to that in Israel?
Provide a succinct answer. 0.33. What is the ratio of the Female students (as % of total students) of Primary education in Iraq to that in Italy?
Keep it short and to the point. 0.92. What is the ratio of the Female students (as % of total students) of Tertiary education in Iraq to that in Italy?
Your response must be concise. 1.21. What is the ratio of the Female students (as % of total students) in Secondary general education in Iraq to that in Italy?
Make the answer very short. 1.02. What is the ratio of the Female students (as % of total students) of Secondary vocational education in Iraq to that in Italy?
Provide a succinct answer. 0.38. What is the ratio of the Female students (as % of total students) in Primary education in Iraq to that in Jamaica?
Ensure brevity in your answer.  0.91. What is the ratio of the Female students (as % of total students) of Tertiary education in Iraq to that in Jamaica?
Make the answer very short. 1.53. What is the ratio of the Female students (as % of total students) in Secondary general education in Iraq to that in Jamaica?
Provide a short and direct response. 1.13. What is the ratio of the Female students (as % of total students) in Secondary vocational education in Iraq to that in Jamaica?
Provide a short and direct response. 1.14. What is the ratio of the Female students (as % of total students) in Primary education in Ireland to that in Israel?
Your response must be concise. 0.98. What is the ratio of the Female students (as % of total students) of Tertiary education in Ireland to that in Israel?
Keep it short and to the point. 1. What is the ratio of the Female students (as % of total students) of Secondary general education in Ireland to that in Israel?
Keep it short and to the point. 1.04. What is the ratio of the Female students (as % of total students) in Secondary vocational education in Ireland to that in Israel?
Give a very brief answer. 0.63. What is the ratio of the Female students (as % of total students) of Primary education in Ireland to that in Italy?
Your response must be concise. 1. What is the ratio of the Female students (as % of total students) in Tertiary education in Ireland to that in Italy?
Offer a terse response. 1.2. What is the ratio of the Female students (as % of total students) of Secondary general education in Ireland to that in Italy?
Offer a very short reply. 1.08. What is the ratio of the Female students (as % of total students) in Secondary vocational education in Ireland to that in Italy?
Offer a very short reply. 0.71. What is the ratio of the Female students (as % of total students) in Primary education in Ireland to that in Jamaica?
Your response must be concise. 0.99. What is the ratio of the Female students (as % of total students) of Tertiary education in Ireland to that in Jamaica?
Ensure brevity in your answer.  1.51. What is the ratio of the Female students (as % of total students) in Secondary general education in Ireland to that in Jamaica?
Keep it short and to the point. 1.2. What is the ratio of the Female students (as % of total students) in Secondary vocational education in Ireland to that in Jamaica?
Your response must be concise. 2.17. What is the ratio of the Female students (as % of total students) in Primary education in Israel to that in Italy?
Provide a succinct answer. 1.02. What is the ratio of the Female students (as % of total students) of Tertiary education in Israel to that in Italy?
Ensure brevity in your answer.  1.19. What is the ratio of the Female students (as % of total students) in Secondary general education in Israel to that in Italy?
Provide a short and direct response. 1.04. What is the ratio of the Female students (as % of total students) in Secondary vocational education in Israel to that in Italy?
Keep it short and to the point. 1.12. What is the ratio of the Female students (as % of total students) of Tertiary education in Israel to that in Jamaica?
Provide a succinct answer. 1.51. What is the ratio of the Female students (as % of total students) of Secondary general education in Israel to that in Jamaica?
Give a very brief answer. 1.15. What is the ratio of the Female students (as % of total students) in Secondary vocational education in Israel to that in Jamaica?
Your response must be concise. 3.41. What is the ratio of the Female students (as % of total students) of Primary education in Italy to that in Jamaica?
Make the answer very short. 0.98. What is the ratio of the Female students (as % of total students) in Tertiary education in Italy to that in Jamaica?
Keep it short and to the point. 1.27. What is the ratio of the Female students (as % of total students) of Secondary general education in Italy to that in Jamaica?
Give a very brief answer. 1.11. What is the ratio of the Female students (as % of total students) in Secondary vocational education in Italy to that in Jamaica?
Your answer should be very brief. 3.04. What is the difference between the highest and the second highest Female students (as % of total students) in Primary education?
Keep it short and to the point. 0.04. What is the difference between the highest and the second highest Female students (as % of total students) in Tertiary education?
Keep it short and to the point. 1.32. What is the difference between the highest and the second highest Female students (as % of total students) in Secondary general education?
Keep it short and to the point. 0.54. What is the difference between the highest and the second highest Female students (as % of total students) in Secondary vocational education?
Offer a terse response. 6.52. What is the difference between the highest and the lowest Female students (as % of total students) of Primary education?
Offer a terse response. 6.62. What is the difference between the highest and the lowest Female students (as % of total students) in Tertiary education?
Make the answer very short. 17.91. What is the difference between the highest and the lowest Female students (as % of total students) of Secondary general education?
Provide a succinct answer. 9.01. What is the difference between the highest and the lowest Female students (as % of total students) of Secondary vocational education?
Your answer should be very brief. 42.24. 